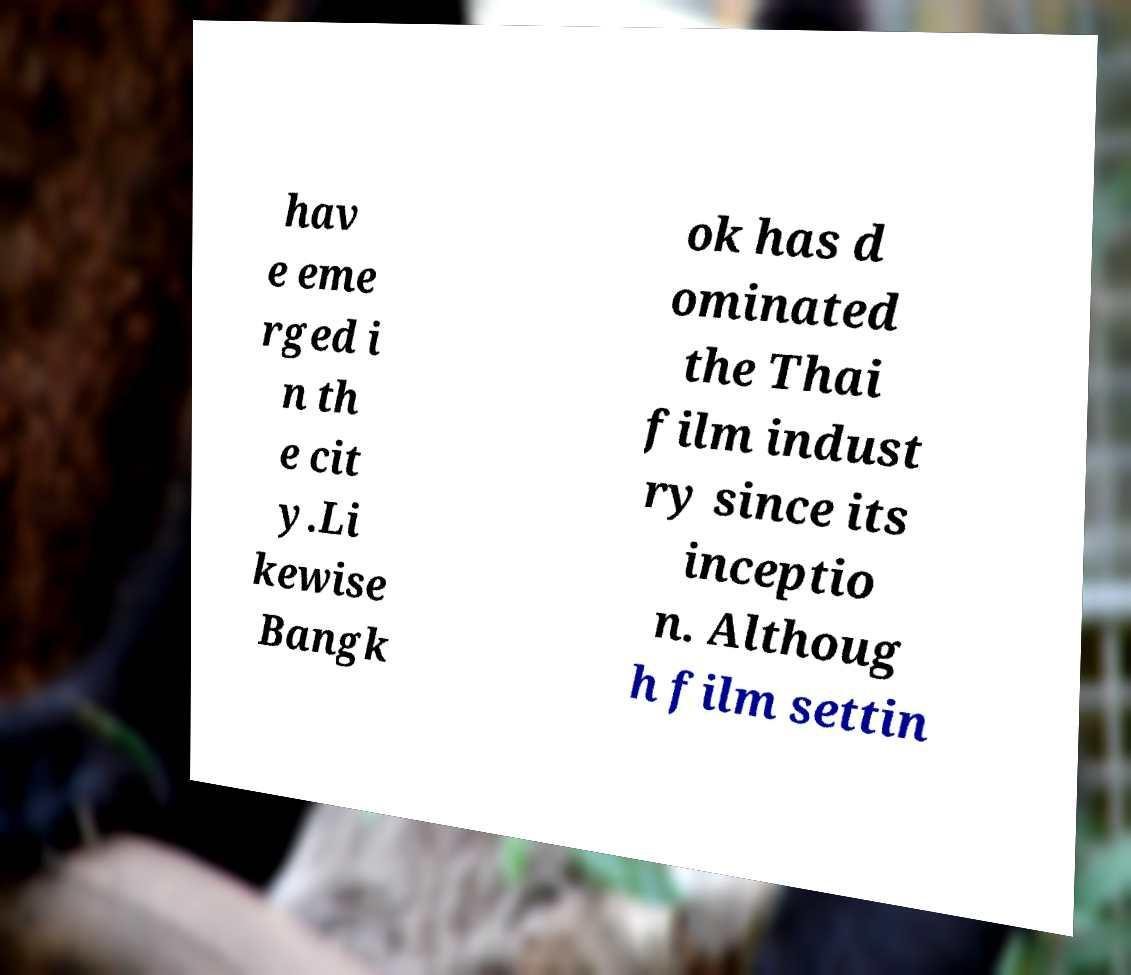Could you assist in decoding the text presented in this image and type it out clearly? hav e eme rged i n th e cit y.Li kewise Bangk ok has d ominated the Thai film indust ry since its inceptio n. Althoug h film settin 